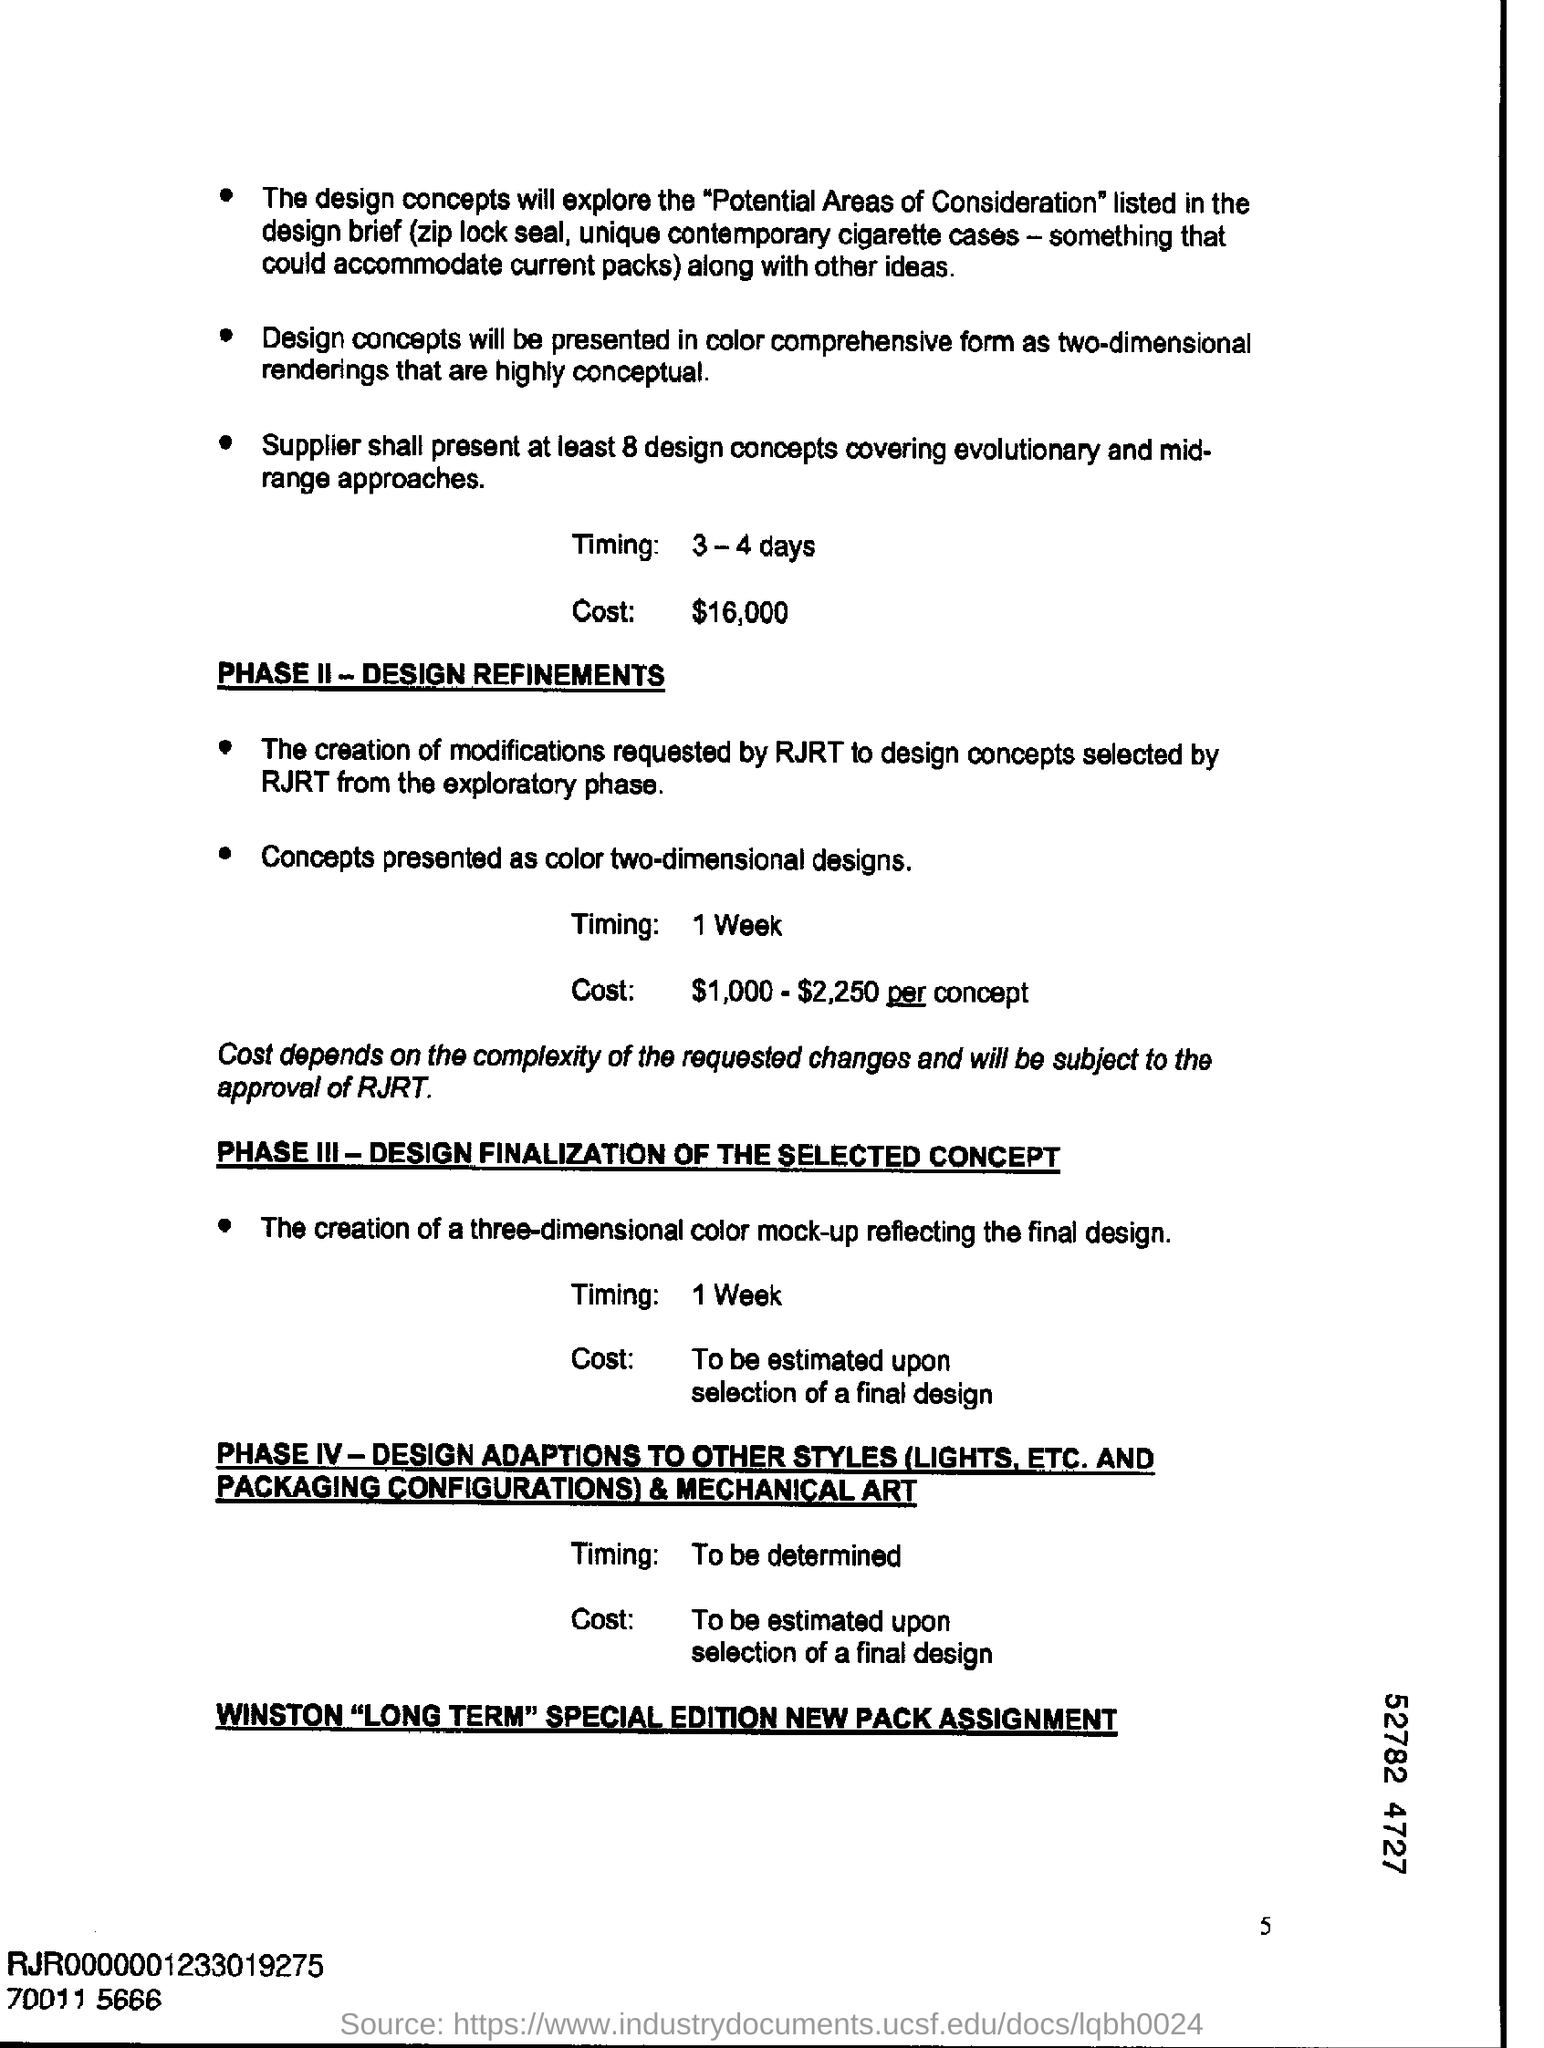What is the timing mentioned ?
Make the answer very short. 3-4 days. What is the cost mentioned ?
Your response must be concise. $16,000. What is the timing mentioned for phase 2?
Ensure brevity in your answer.  1 week. What is the cost mentioned for phas 2 ?
Provide a succinct answer. $ 1,000-$ 2,250 per concept. What is the timing mentioned for phase 3?
Your response must be concise. 1 week. 